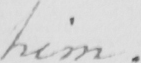Please provide the text content of this handwritten line. him . 